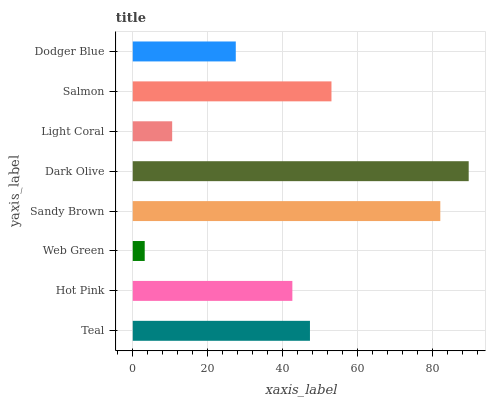Is Web Green the minimum?
Answer yes or no. Yes. Is Dark Olive the maximum?
Answer yes or no. Yes. Is Hot Pink the minimum?
Answer yes or no. No. Is Hot Pink the maximum?
Answer yes or no. No. Is Teal greater than Hot Pink?
Answer yes or no. Yes. Is Hot Pink less than Teal?
Answer yes or no. Yes. Is Hot Pink greater than Teal?
Answer yes or no. No. Is Teal less than Hot Pink?
Answer yes or no. No. Is Teal the high median?
Answer yes or no. Yes. Is Hot Pink the low median?
Answer yes or no. Yes. Is Light Coral the high median?
Answer yes or no. No. Is Light Coral the low median?
Answer yes or no. No. 